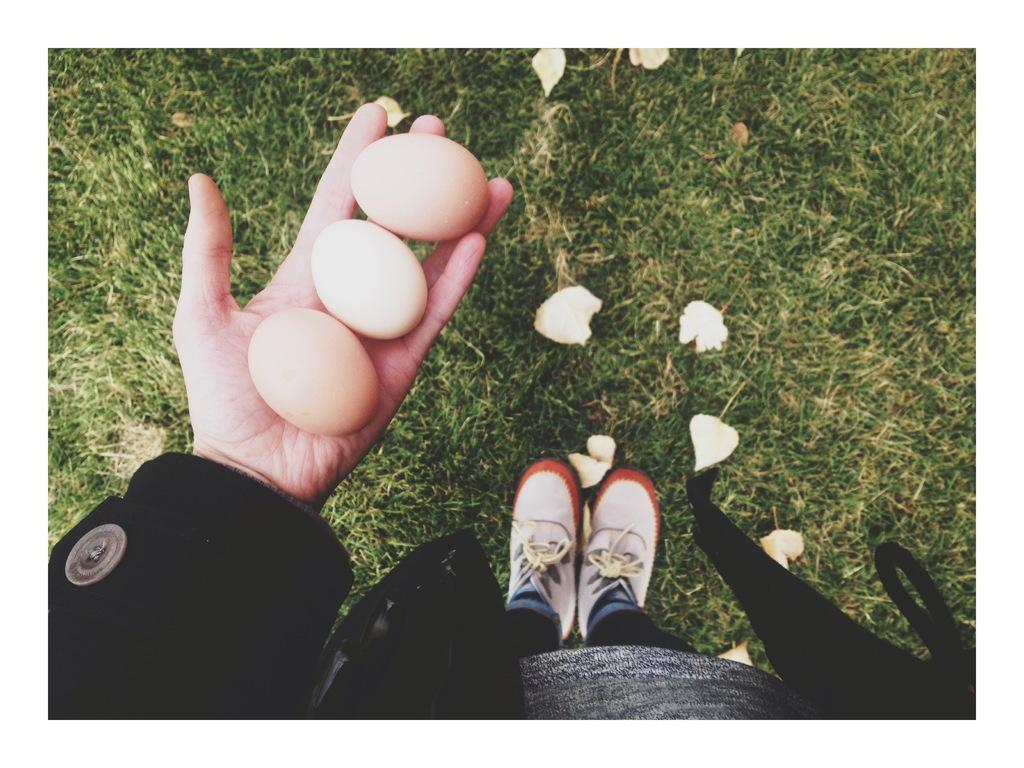Who is present in the image? There is a person in the image. What is the person wearing? The person is wearing clothes. What is the person holding in their hand? There are eggs in the person's hand. What type of vegetation can be seen on the ground in the image? There is grass and leaves on the ground in the image. What type of cork can be seen in the person's hand? There is no cork present in the image; the person is holding eggs. 